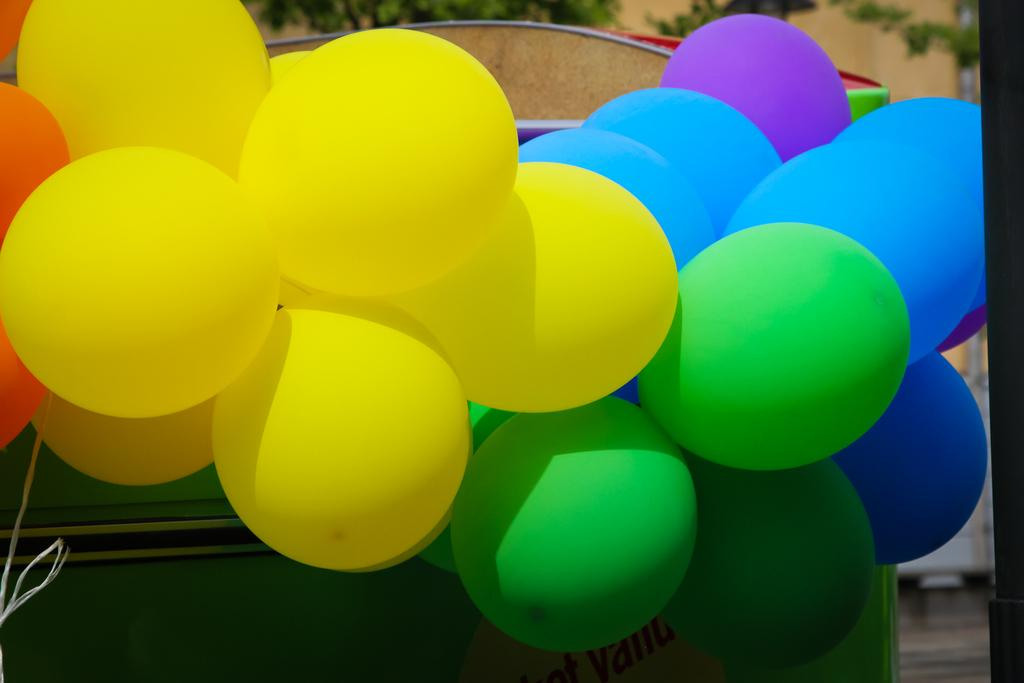What objects are present in the image? There are balloons in the image. Can you describe the balloons in more detail? The balloons are in different colors, including red, yellow, blue, and purple. What can be seen in the background of the image? There are trees in the background of the image. What type of bone can be seen in the image? There is no bone present in the image; it features balloons in different colors and trees in the background. 